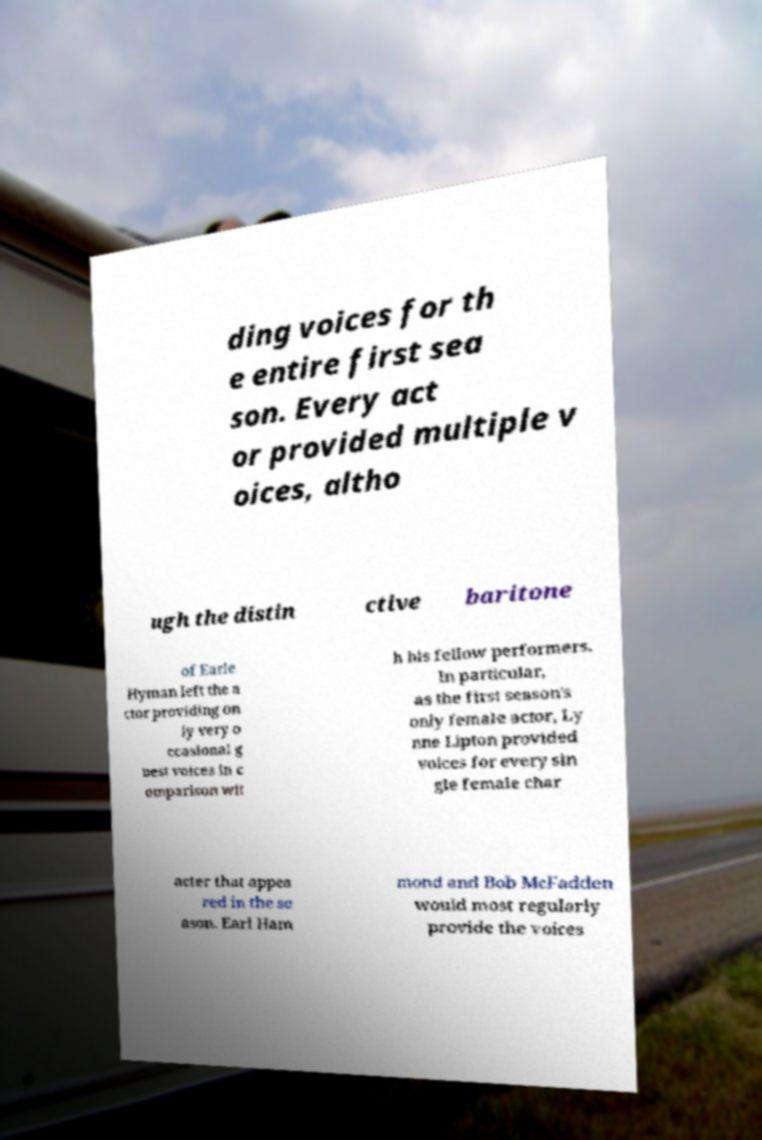I need the written content from this picture converted into text. Can you do that? ding voices for th e entire first sea son. Every act or provided multiple v oices, altho ugh the distin ctive baritone of Earle Hyman left the a ctor providing on ly very o ccasional g uest voices in c omparison wit h his fellow performers. In particular, as the first season's only female actor, Ly nne Lipton provided voices for every sin gle female char acter that appea red in the se ason. Earl Ham mond and Bob McFadden would most regularly provide the voices 